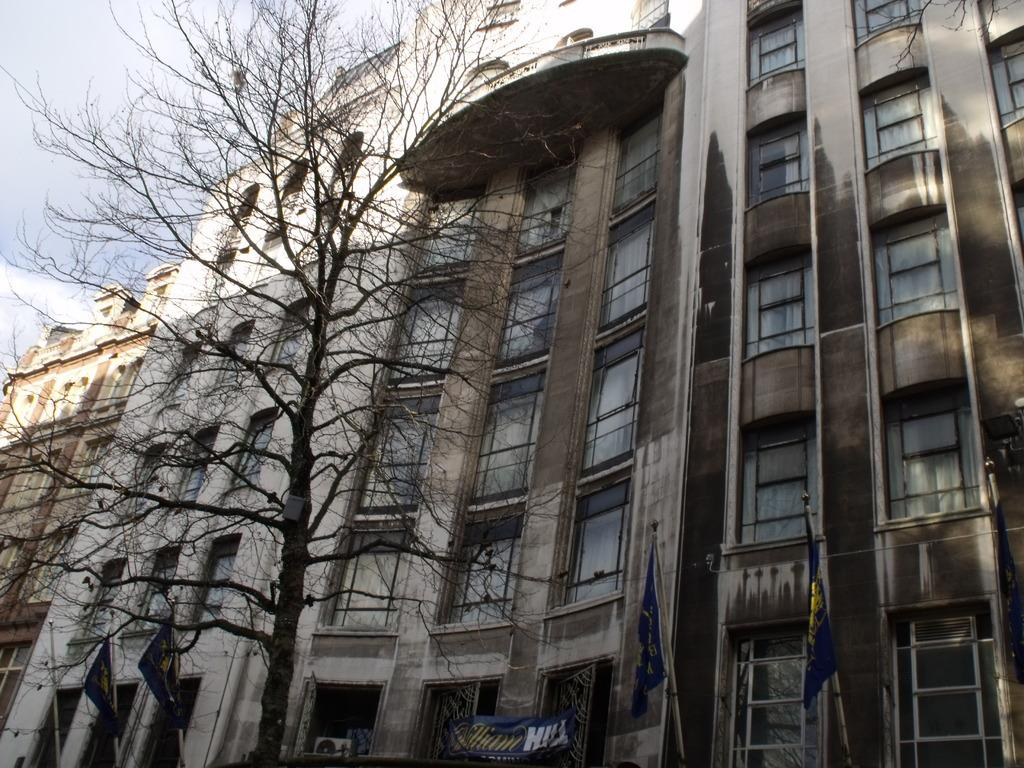What type of structures can be seen in the image? There are buildings with windows in the image. What is located at the bottom of the image? There is a banner at the bottom of the image. What is hanging from poles in the image? Flags are hanging from poles in the image. What type of plant is visible in the image? There is a tree with branches in the image. Can you see your aunt's toe in the image? There is no reference to an aunt or a toe in the image, so it is not possible to answer that question. 